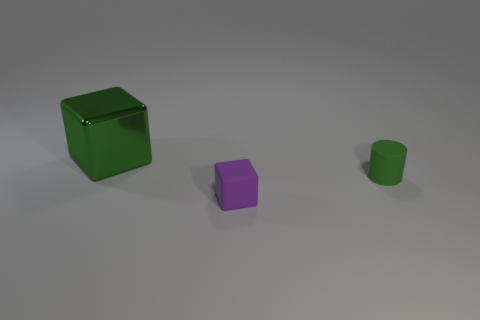Add 1 small yellow cylinders. How many objects exist? 4 Subtract all cubes. How many objects are left? 1 Subtract all tiny green rubber objects. Subtract all green blocks. How many objects are left? 1 Add 1 purple things. How many purple things are left? 2 Add 3 large blue metallic things. How many large blue metallic things exist? 3 Subtract 1 green cylinders. How many objects are left? 2 